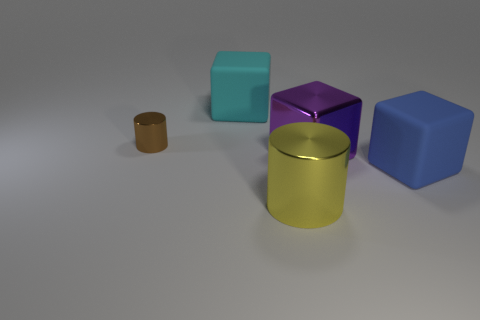Add 1 big yellow metal blocks. How many objects exist? 6 Subtract all cubes. How many objects are left? 2 Add 4 large cylinders. How many large cylinders are left? 5 Add 1 small yellow balls. How many small yellow balls exist? 1 Subtract 0 blue balls. How many objects are left? 5 Subtract all small brown objects. Subtract all large blocks. How many objects are left? 1 